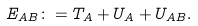<formula> <loc_0><loc_0><loc_500><loc_500>E _ { A B } \colon = T _ { A } + U _ { A } + U _ { A B } .</formula> 